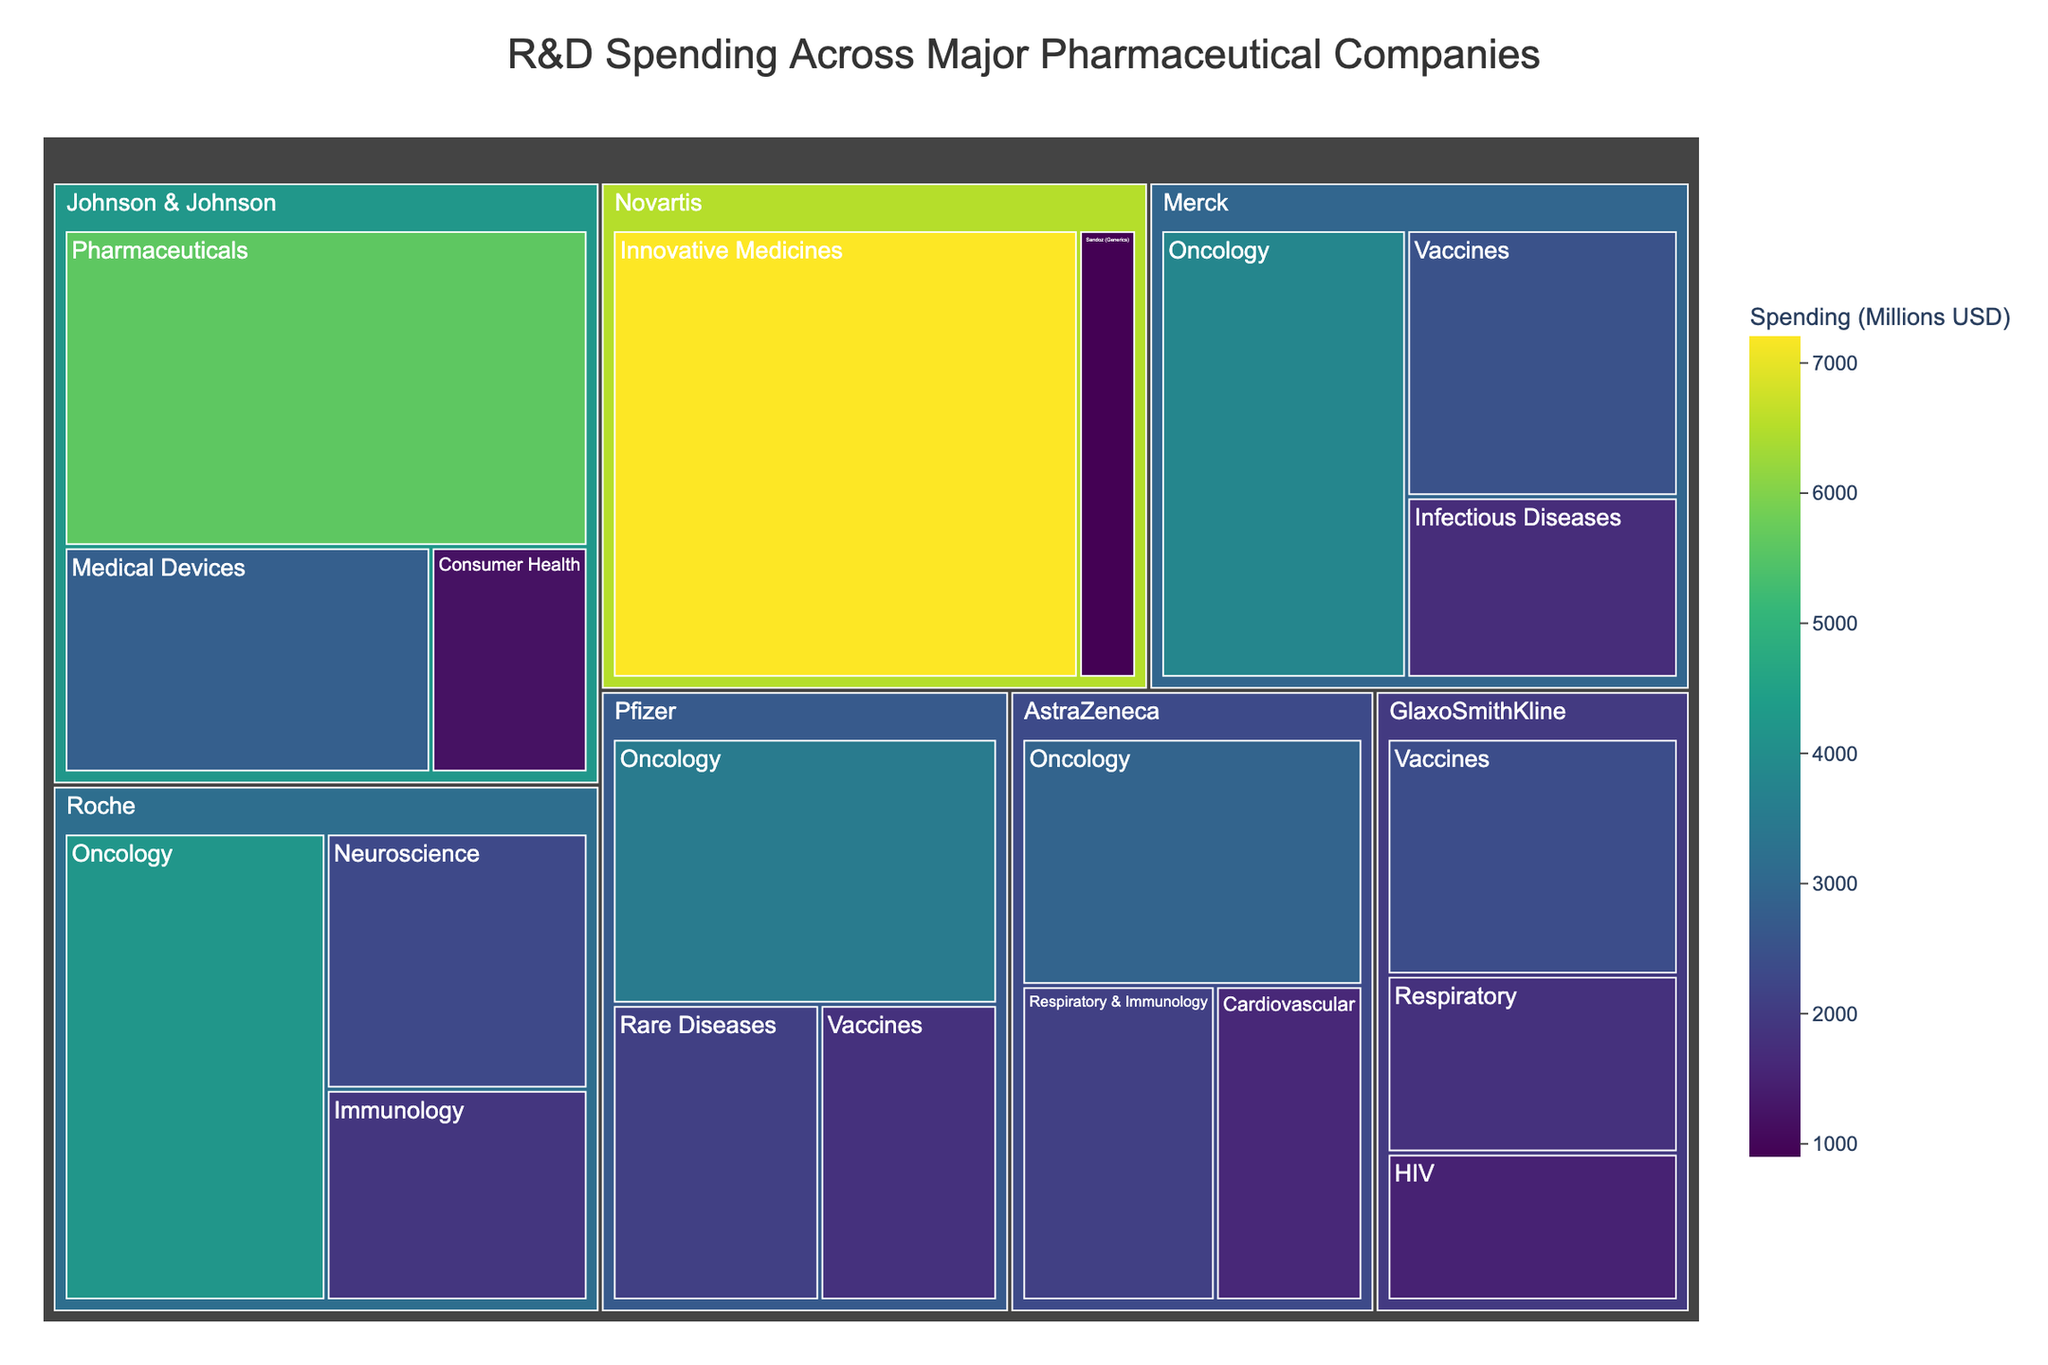Which company has the highest overall R&D spending? To determine the company with the highest overall R&D spending, look for the largest block in the treemap since it represents total spending across all categories for that company. Novartis has the largest block, indicating the highest spending.
Answer: Novartis How much does Johnson & Johnson spend on Medical Devices and Consumer Health combined? Johnson & Johnson's spending on Medical Devices is 2800 million, and on Consumer Health is 1200 million. Adding these amounts gives 2800 + 1200 = 4000 million.
Answer: 4000 million Which category does Roche spend the most on? Locate Roche on the treemap and identify the category with the largest block. In this case, Oncology has the largest block under Roche.
Answer: Oncology Compare the R&D spending on Oncology between Pfizer and AstraZeneca. Which company spends more? Find the Oncology blocks under both Pfizer and AstraZeneca. Pfizer's spending on Oncology is 3500 million, and AstraZeneca's spending is 2900 million. Pfizer spends more.
Answer: Pfizer What is the total R&D spending on Vaccines across all companies? Sum the R&D spending on Vaccines for Pfizer (1800 million), Merck (2500 million), and GlaxoSmithKline (2400 million). The total is 1800 + 2500 + 2400 = 6700 million.
Answer: 6700 million Rank the companies based on their total R&D spending on Oncology. To rank the companies, list their spending on Oncology: Roche (4200 million), Merck (3800 million), Pfizer (3500 million), AstraZeneca (2900 million). The rank from highest to lowest is: Roche, Merck, Pfizer, AstraZeneca.
Answer: Roche, Merck, Pfizer, AstraZeneca Which company has the smallest R&D spending in any category, and what is that amount? Look for the smallest block in the treemap, which represents the smallest spending in any category. Novartis' Sandoz (Generics) has the smallest block with a spending of 900 million.
Answer: Novartis, 900 million What is the difference in R&D spending on Innovative Medicines and Sandoz (Generics) for Novartis? Novartis spends 7200 million on Innovative Medicines and 900 million on Sandoz (Generics). The difference is 7200 - 900 = 6300 million.
Answer: 6300 million How does the R&D spending on Rare Diseases by Pfizer compare with Infectious Diseases by Merck? Pfizer's spending on Rare Diseases is 2100 million, and Merck's spending on Infectious Diseases is 1700 million. Pfizer spends more on Rare Diseases.
Answer: Pfizer Which company spends more on Respiratory-related research? GlaxoSmithKline spends 1800 million on Respiratory and AstraZeneca spends 2100 million on Respiratory & Immunology. AstraZeneca spends more on Respiratory-related research.
Answer: AstraZeneca 